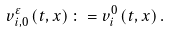Convert formula to latex. <formula><loc_0><loc_0><loc_500><loc_500>v _ { i , 0 } ^ { \varepsilon } \left ( t , x \right ) \colon = v _ { i } ^ { 0 } \left ( t , x \right ) .</formula> 